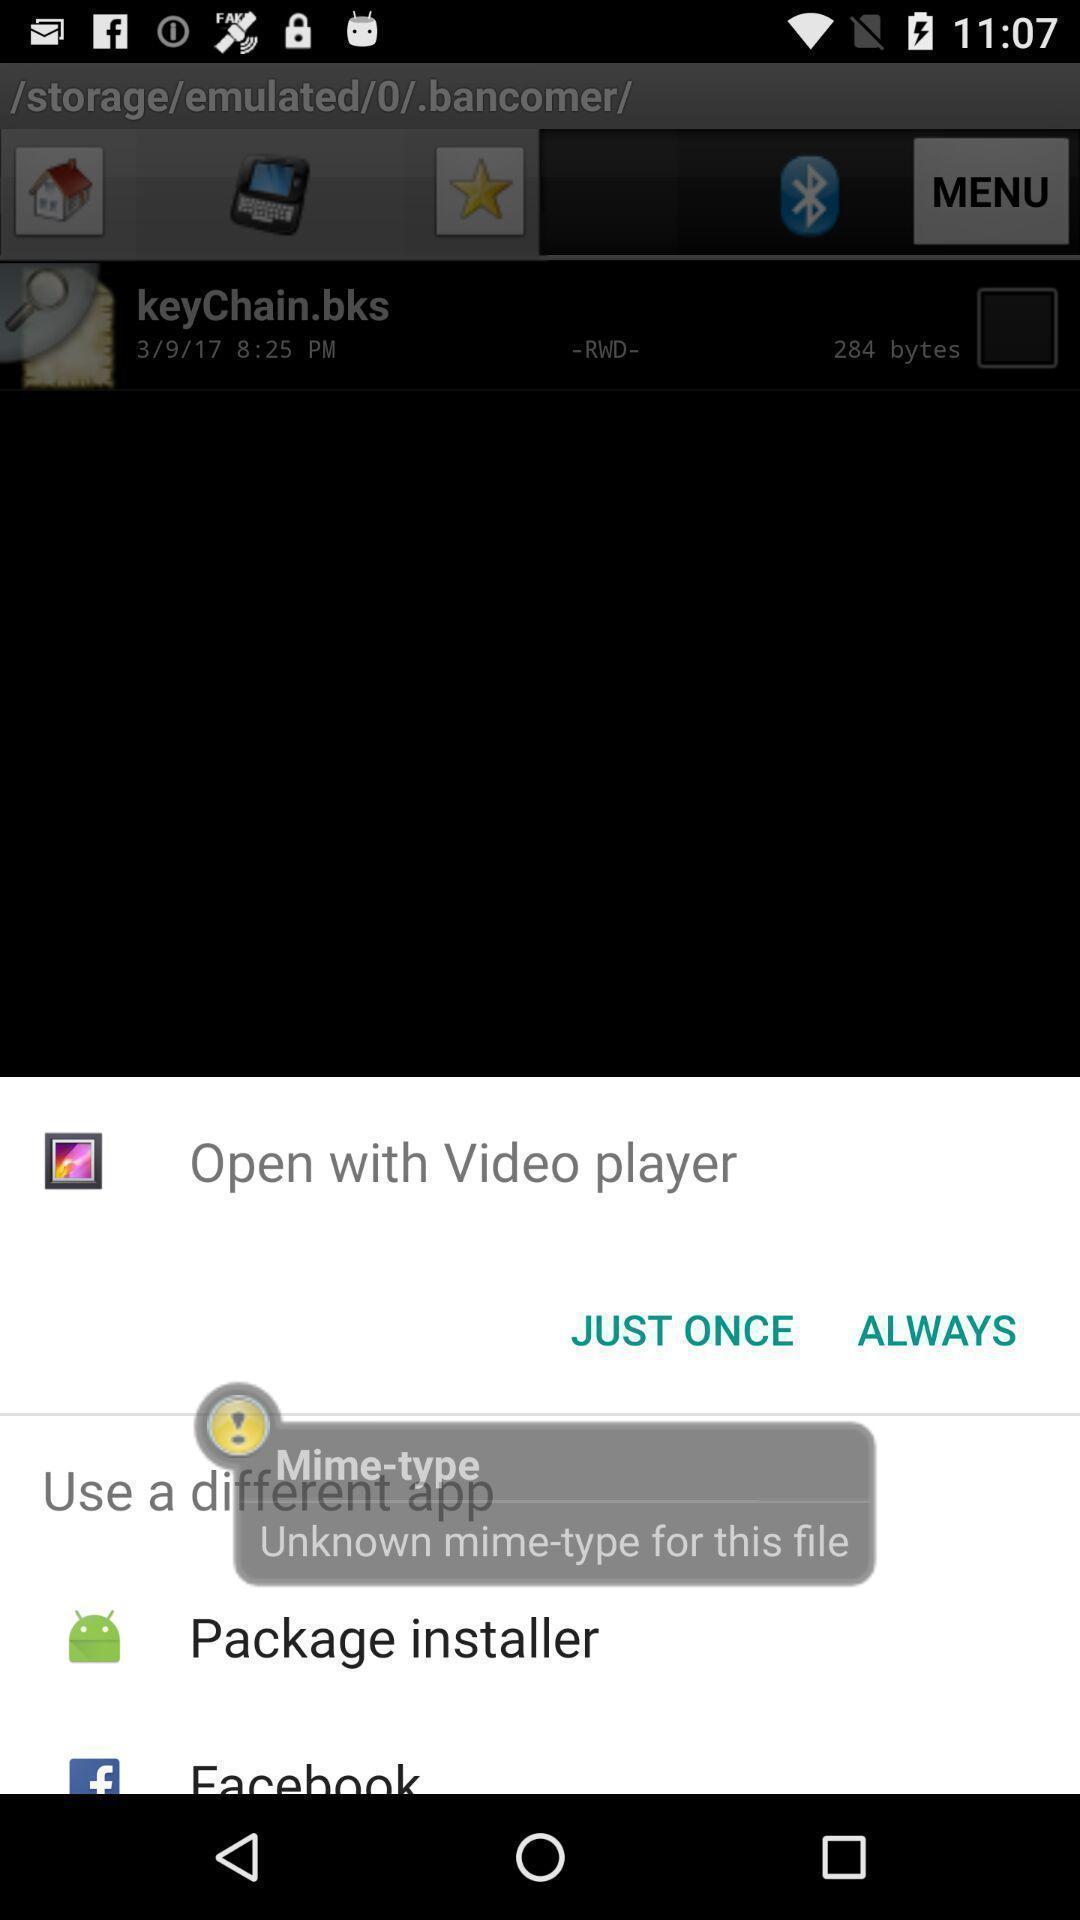Please provide a description for this image. Pop-up to open video player via different apps. 